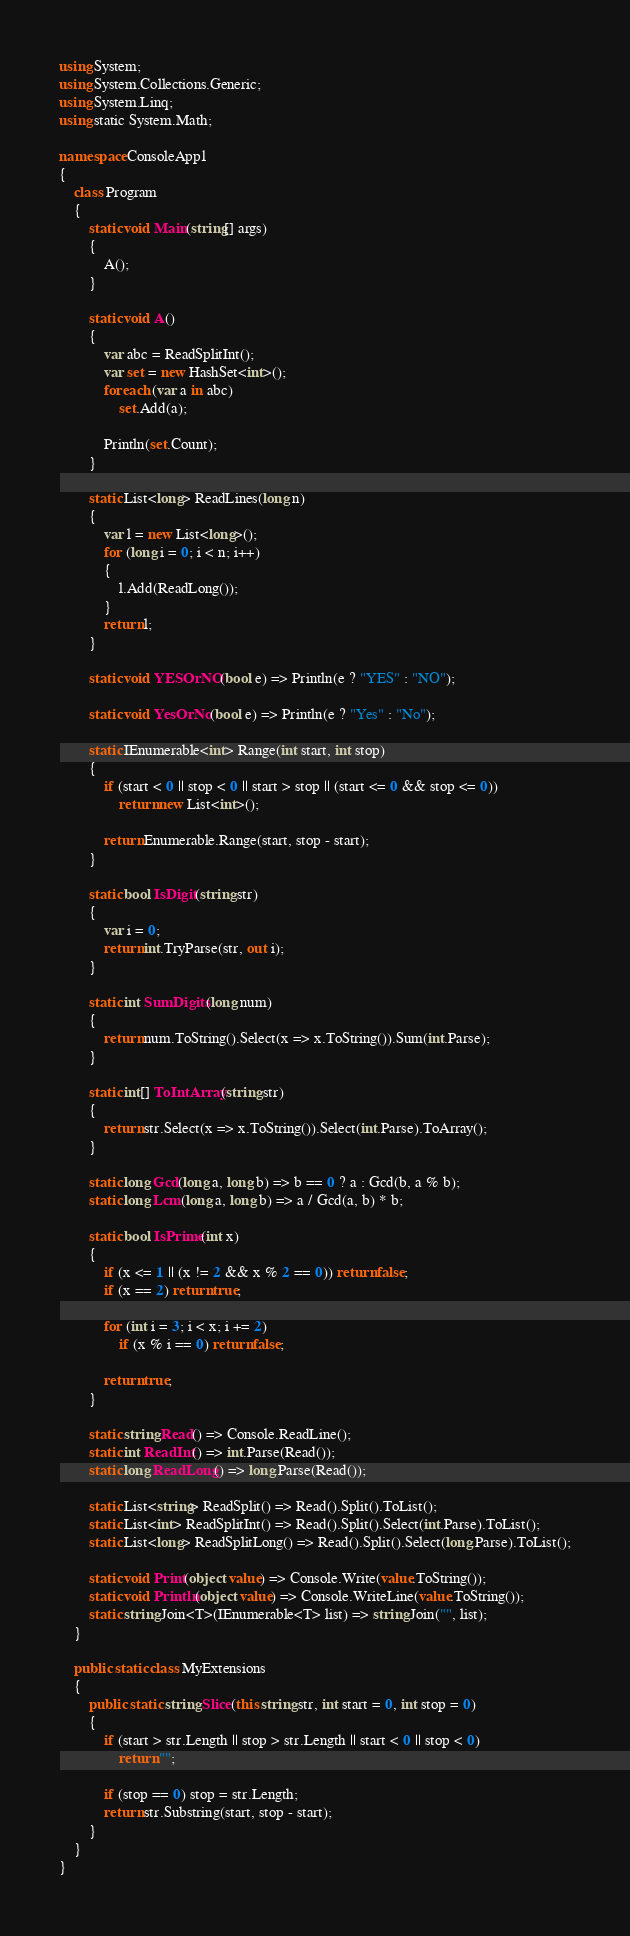Convert code to text. <code><loc_0><loc_0><loc_500><loc_500><_C#_>using System;
using System.Collections.Generic;
using System.Linq;
using static System.Math;

namespace ConsoleApp1
{
    class Program
    {
        static void Main(string[] args)
        {
            A();
        }

        static void A()
        {
            var abc = ReadSplitInt();
            var set = new HashSet<int>();
            foreach (var a in abc)
                set.Add(a);

            Println(set.Count);
        }

        static List<long> ReadLines(long n)
        {
            var l = new List<long>();
            for (long i = 0; i < n; i++)
            {
                l.Add(ReadLong());
            }
            return l;
        }

        static void YESOrNO(bool e) => Println(e ? "YES" : "NO");

        static void YesOrNo(bool e) => Println(e ? "Yes" : "No");

        static IEnumerable<int> Range(int start, int stop)
        {
            if (start < 0 || stop < 0 || start > stop || (start <= 0 && stop <= 0))
                return new List<int>();

            return Enumerable.Range(start, stop - start);
        }

        static bool IsDigit(string str)
        {
            var i = 0;
            return int.TryParse(str, out i);
        }

        static int SumDigits(long num)
        {
            return num.ToString().Select(x => x.ToString()).Sum(int.Parse);
        }

        static int[] ToIntArray(string str)
        {
            return str.Select(x => x.ToString()).Select(int.Parse).ToArray();
        }

        static long Gcd(long a, long b) => b == 0 ? a : Gcd(b, a % b);
        static long Lcm(long a, long b) => a / Gcd(a, b) * b;

        static bool IsPrime(int x)
        {
            if (x <= 1 || (x != 2 && x % 2 == 0)) return false;
            if (x == 2) return true;

            for (int i = 3; i < x; i += 2)
                if (x % i == 0) return false;

            return true;
        }

        static string Read() => Console.ReadLine();
        static int ReadInt() => int.Parse(Read());
        static long ReadLong() => long.Parse(Read());

        static List<string> ReadSplit() => Read().Split().ToList();
        static List<int> ReadSplitInt() => Read().Split().Select(int.Parse).ToList();
        static List<long> ReadSplitLong() => Read().Split().Select(long.Parse).ToList();

        static void Print(object value) => Console.Write(value.ToString());
        static void Println(object value) => Console.WriteLine(value.ToString());
        static string Join<T>(IEnumerable<T> list) => string.Join("", list);
    }

    public static class MyExtensions
    {
        public static string Slice(this string str, int start = 0, int stop = 0)
        {
            if (start > str.Length || stop > str.Length || start < 0 || stop < 0)
                return "";

            if (stop == 0) stop = str.Length;
            return str.Substring(start, stop - start);
        }
    }
}

</code> 